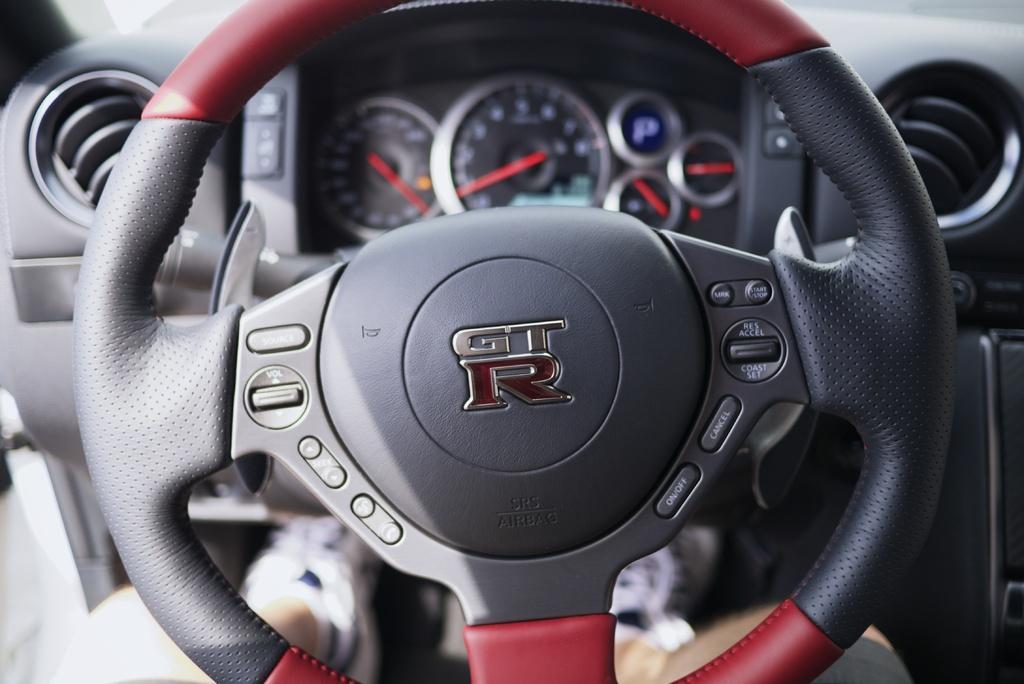How would you summarize this image in a sentence or two? In the image we can see a steering part of the vehicle and this is a speedometer. 